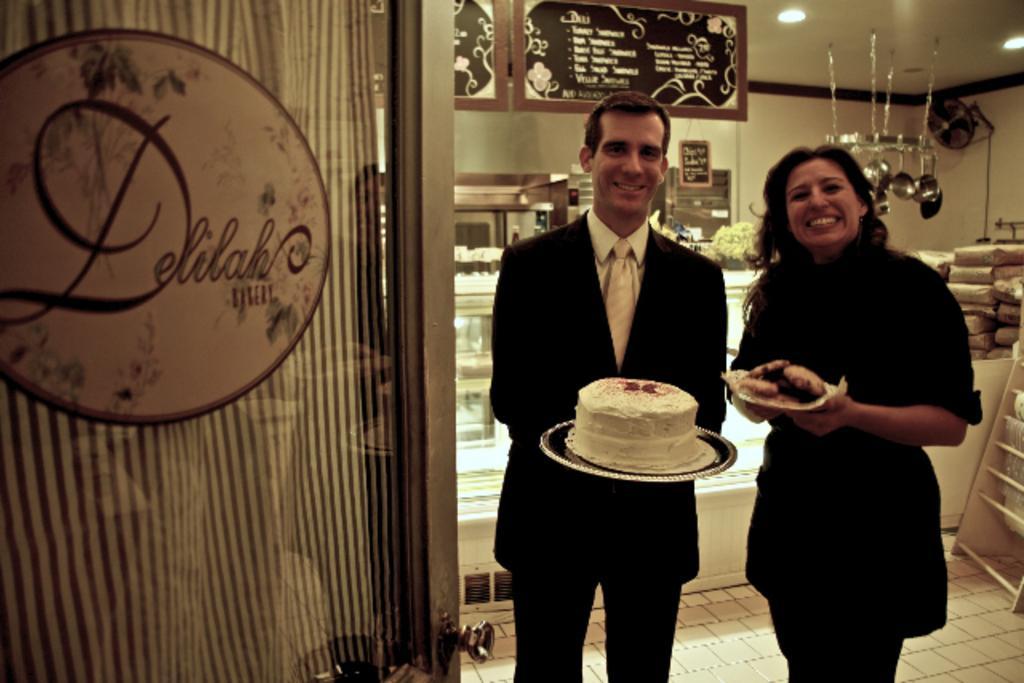Can you describe this image briefly? In this image we can see two people holding the objects, around them there are some other objects, at the top of the roof, we can see some lights and other objects hanged, on the left side we can see a door and a curtain with the board. 